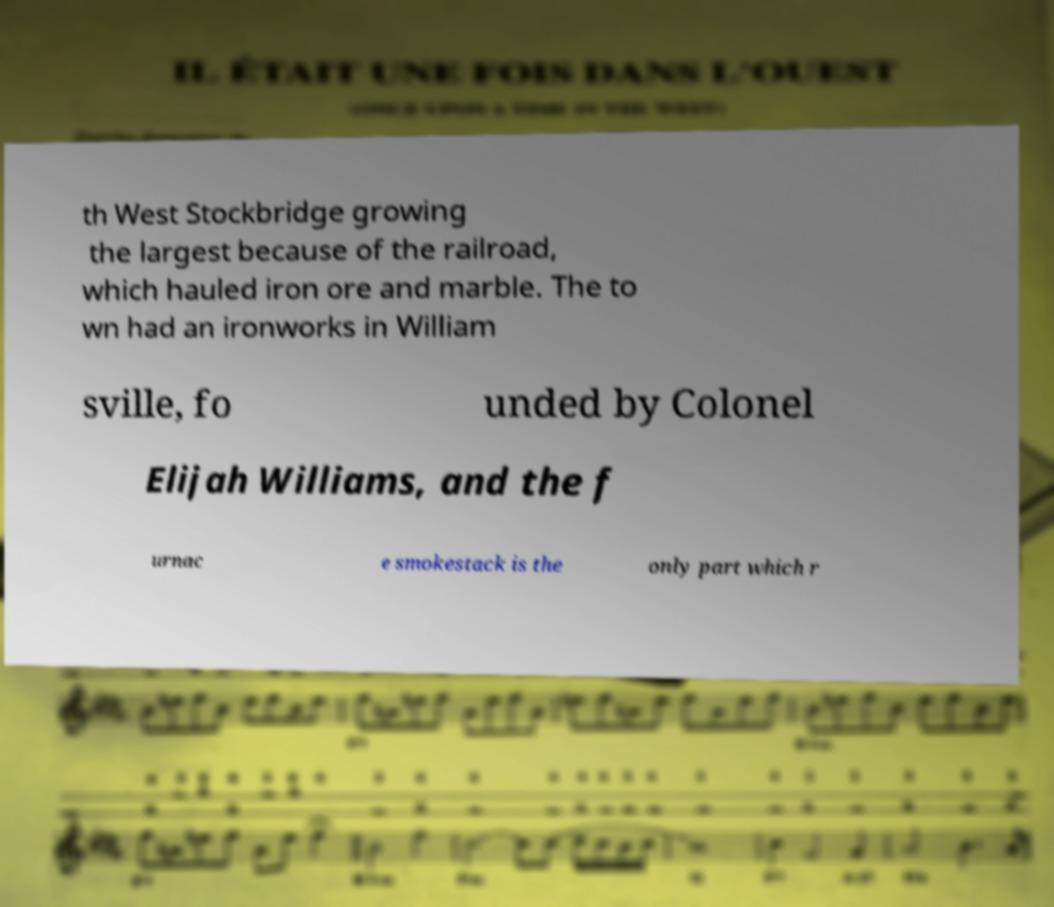I need the written content from this picture converted into text. Can you do that? th West Stockbridge growing the largest because of the railroad, which hauled iron ore and marble. The to wn had an ironworks in William sville, fo unded by Colonel Elijah Williams, and the f urnac e smokestack is the only part which r 